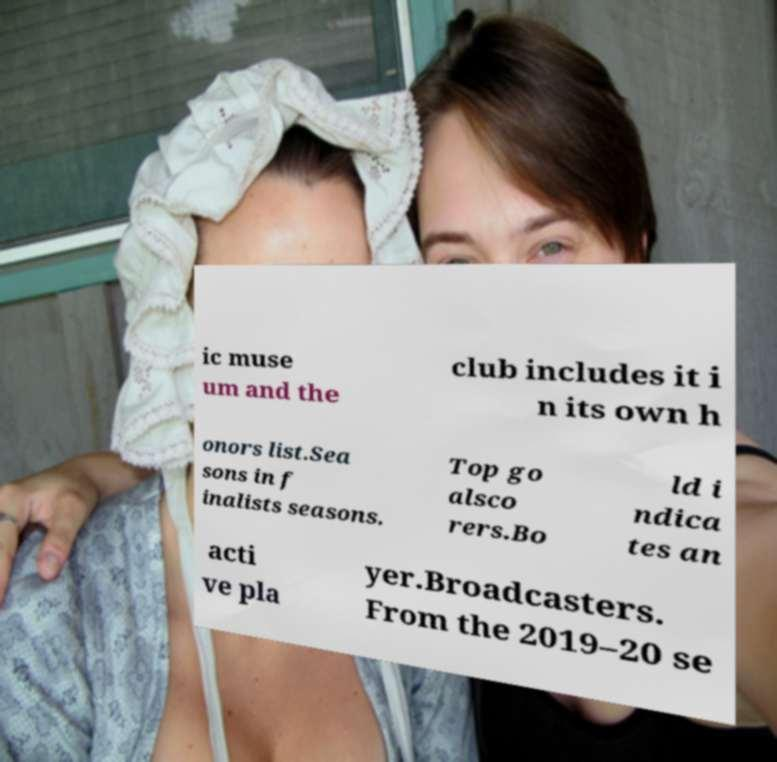There's text embedded in this image that I need extracted. Can you transcribe it verbatim? ic muse um and the club includes it i n its own h onors list.Sea sons in f inalists seasons. Top go alsco rers.Bo ld i ndica tes an acti ve pla yer.Broadcasters. From the 2019–20 se 